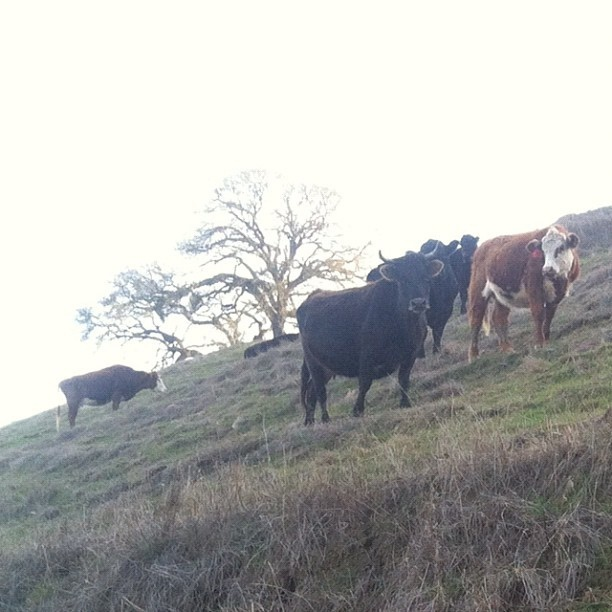Describe the objects in this image and their specific colors. I can see cow in ivory, gray, darkblue, and black tones, cow in ivory, gray, darkgray, and lightgray tones, cow in ivory, gray, darkgray, and lightgray tones, cow in ivory, gray, darkblue, and darkgray tones, and cow in ivory, gray, and darkgray tones in this image. 